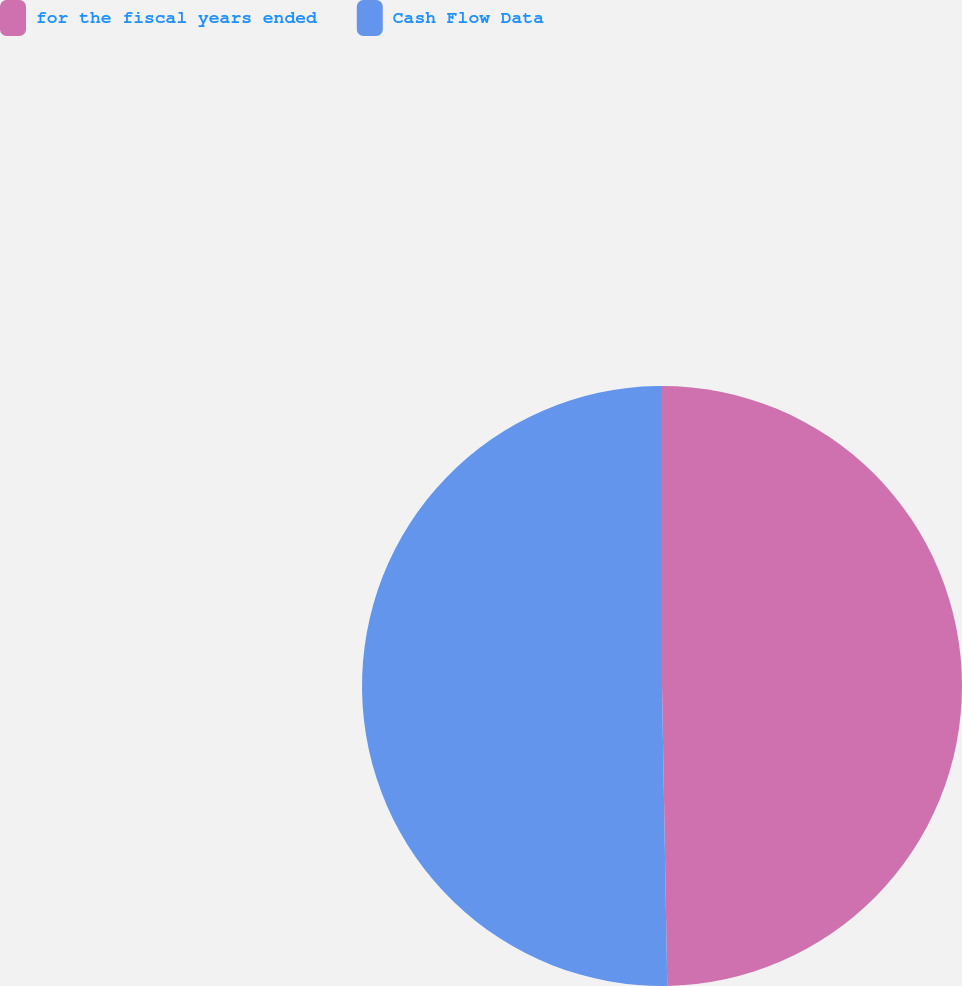Convert chart. <chart><loc_0><loc_0><loc_500><loc_500><pie_chart><fcel>for the fiscal years ended<fcel>Cash Flow Data<nl><fcel>49.72%<fcel>50.28%<nl></chart> 